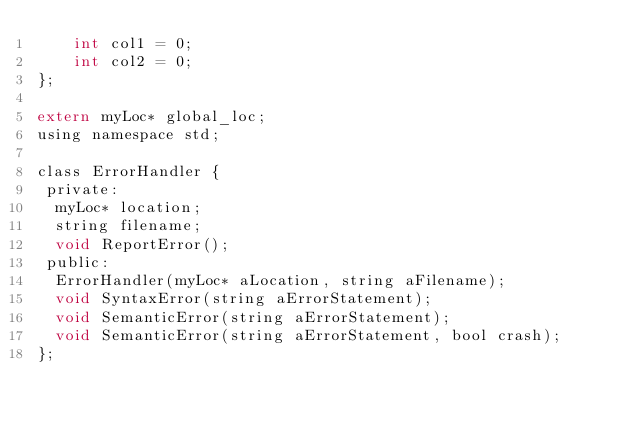Convert code to text. <code><loc_0><loc_0><loc_500><loc_500><_C_>    int col1 = 0;
    int col2 = 0;
};

extern myLoc* global_loc;
using namespace std;

class ErrorHandler {
 private:
  myLoc* location;
  string filename;
  void ReportError();
 public:
  ErrorHandler(myLoc* aLocation, string aFilename);
  void SyntaxError(string aErrorStatement);
  void SemanticError(string aErrorStatement);
  void SemanticError(string aErrorStatement, bool crash);
};

</code> 